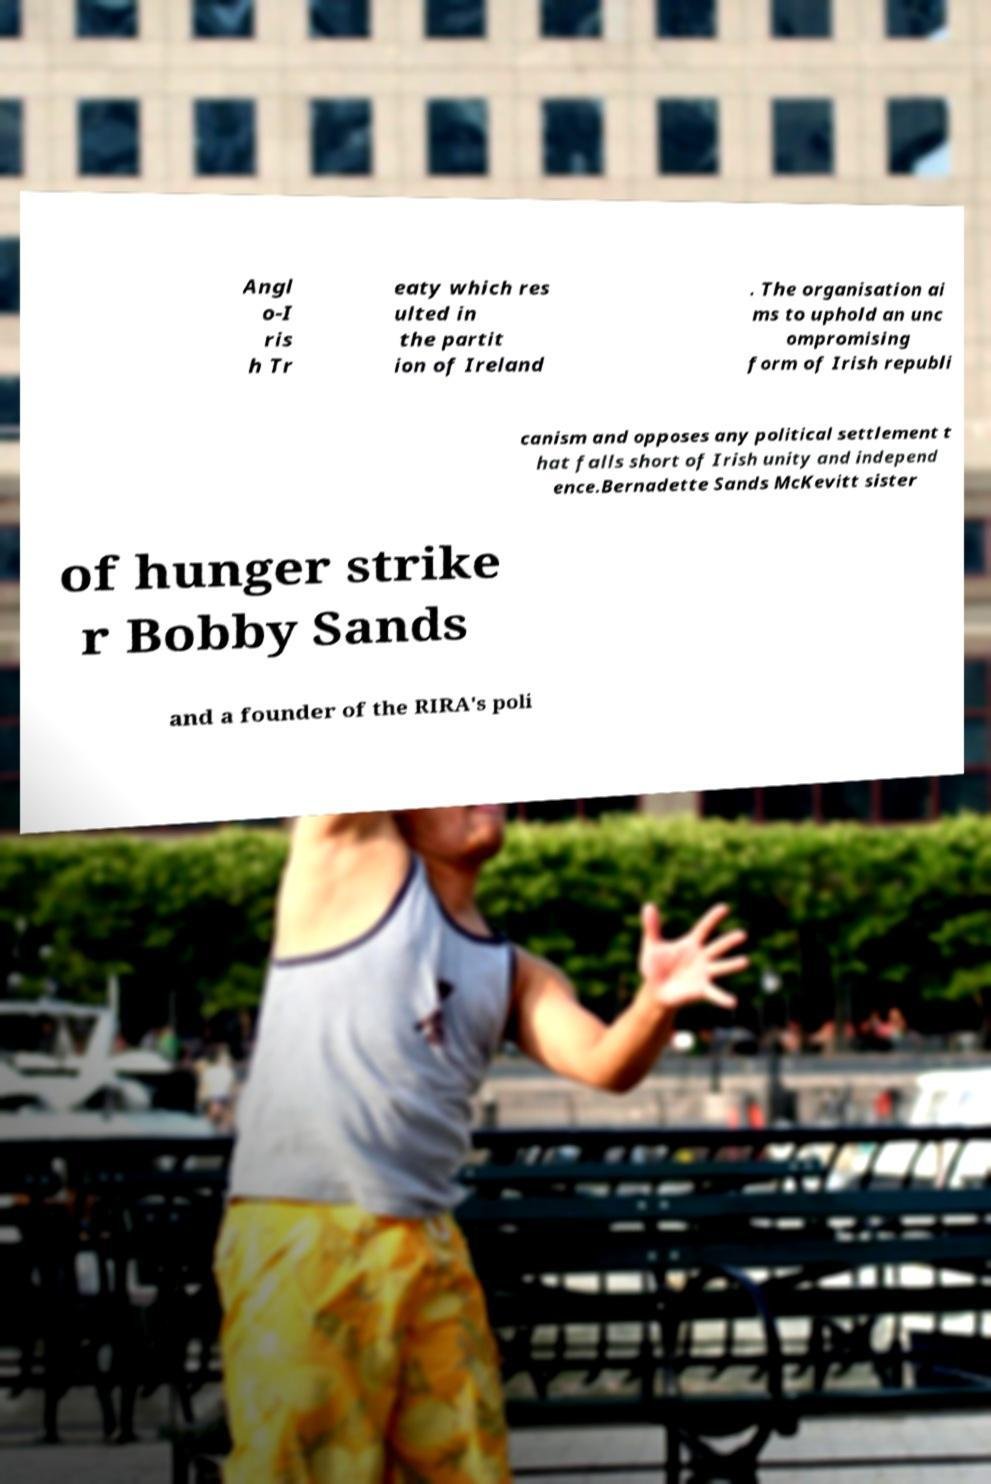Please identify and transcribe the text found in this image. Angl o-I ris h Tr eaty which res ulted in the partit ion of Ireland . The organisation ai ms to uphold an unc ompromising form of Irish republi canism and opposes any political settlement t hat falls short of Irish unity and independ ence.Bernadette Sands McKevitt sister of hunger strike r Bobby Sands and a founder of the RIRA's poli 